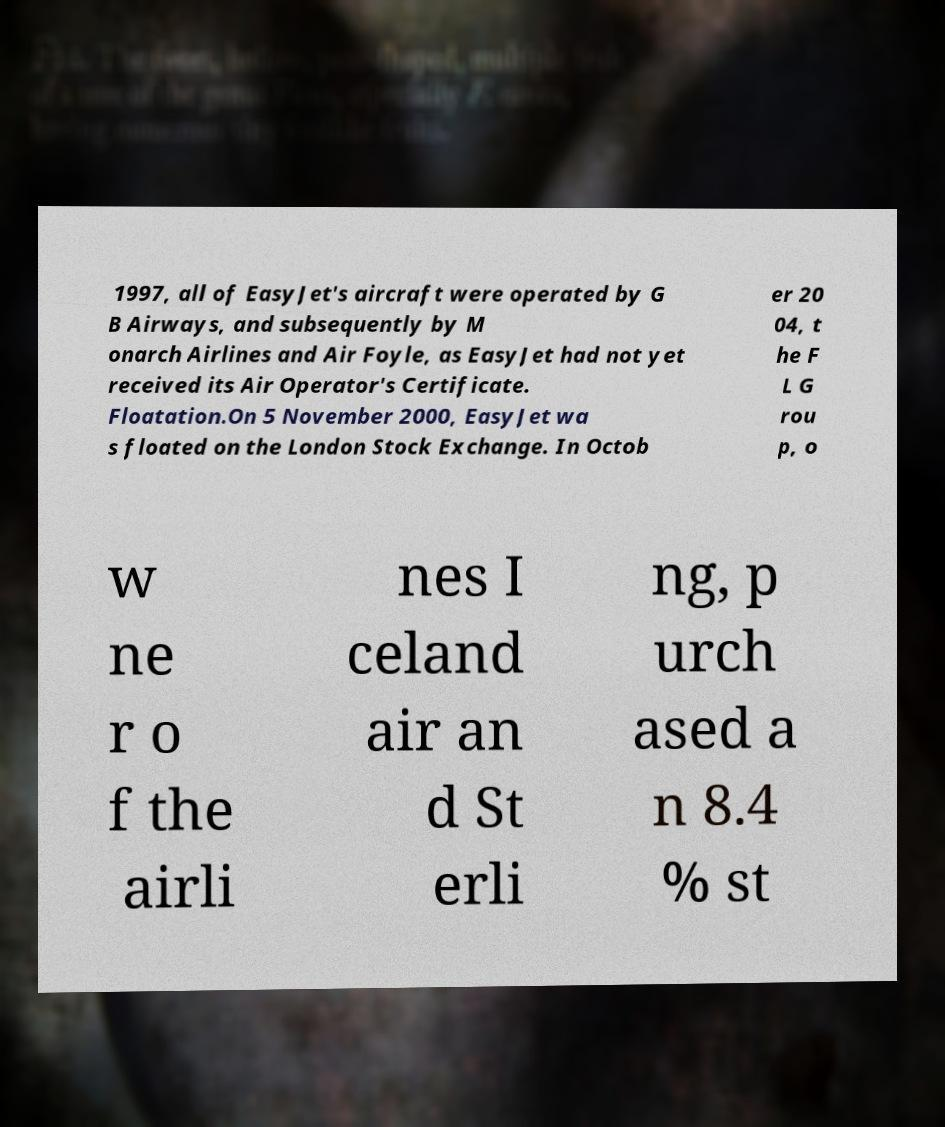Please read and relay the text visible in this image. What does it say? 1997, all of EasyJet's aircraft were operated by G B Airways, and subsequently by M onarch Airlines and Air Foyle, as EasyJet had not yet received its Air Operator's Certificate. Floatation.On 5 November 2000, EasyJet wa s floated on the London Stock Exchange. In Octob er 20 04, t he F L G rou p, o w ne r o f the airli nes I celand air an d St erli ng, p urch ased a n 8.4 % st 